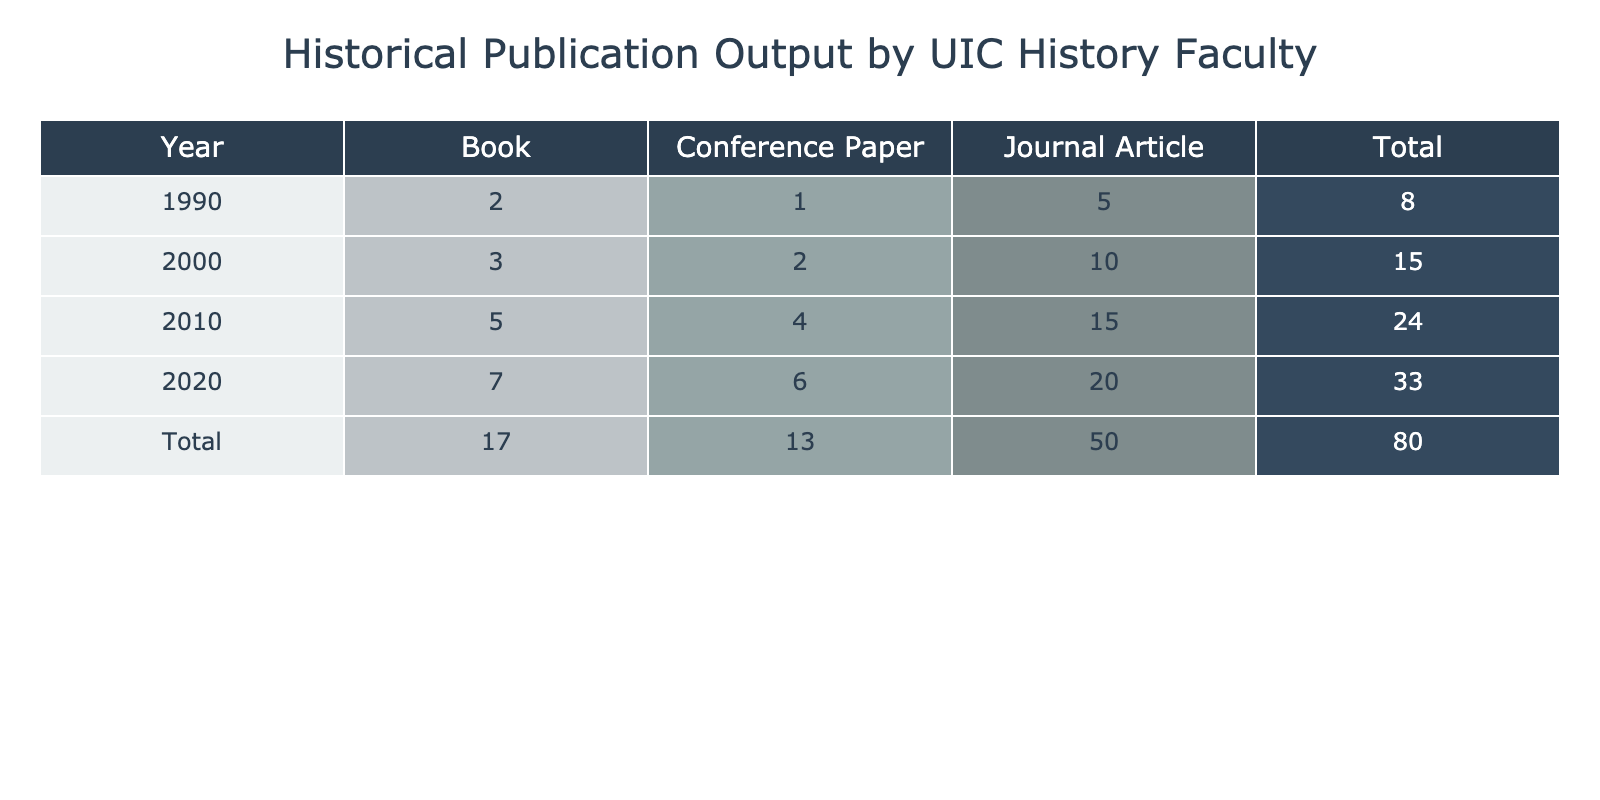What was the total number of journal articles published by UIC history faculty in 2010? In 2010, the table shows that there were 15 journal articles published.
Answer: 15 How many publications were made by UIC history faculty in 2020? In 2020, the total number of publications can be determined by summing the individual publication types: Journal Articles (20), Books (7), and Conference Papers (6), which equals 20 + 7 + 6 = 33.
Answer: 33 Did UIC history faculty publish more books in 2000 than in 1990? The table indicates 3 books were published in 2000 and 2 books in 1990, making the statement true.
Answer: Yes What is the difference between the number of conference papers published in 2010 and in 2020? In 2010, 4 conference papers were published while in 2020 there were 6. To find the difference, subtract 4 from 6, giving a result of 2.
Answer: 2 Which year saw the highest number of total publications and what is that total? By inspecting the total publications for each year, we see that 2020 has the highest total with 33 publications, while 1990 had 8 and 2010 had 24. The answer can be confirmed by comparing the totals.
Answer: 33 How did the number of journal articles change from 2000 to 2010? In 2000, there were 10 journal articles published and in 2010, there were 15. The change can be calculated by subtracting 10 from 15, resulting in an increase of 5 journal articles.
Answer: Increased by 5 What was the overall trend in publication types from 1990 to 2020? By reviewing the years and publication types, we see a clear upward trend in the number of publications for all types across the years, particularly in journal articles and the overall total, leading to the conclusion that there is a general increase in the publication output.
Answer: Increasing trend Did the number of publications fall between 1990 and 2000? The table shows a total for 1990 of 8 publications and a total for 2000 of 15 publications. Since 15 is greater than 8, there was no fall in publications during this period.
Answer: No 